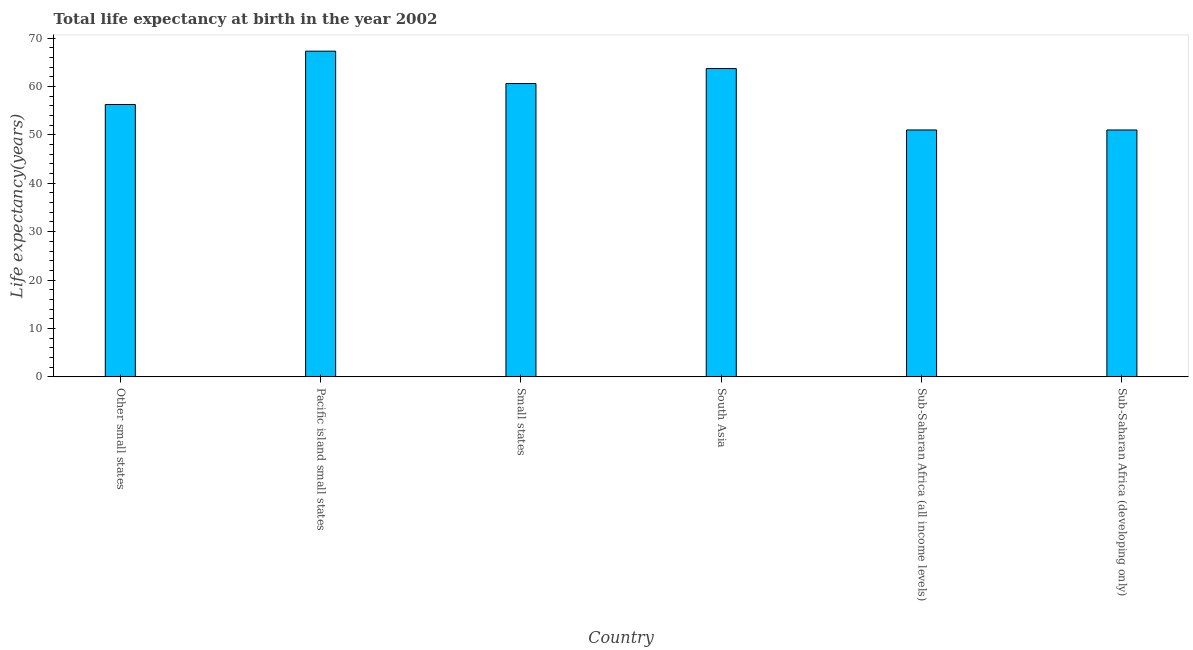Does the graph contain any zero values?
Give a very brief answer. No. What is the title of the graph?
Ensure brevity in your answer.  Total life expectancy at birth in the year 2002. What is the label or title of the X-axis?
Provide a short and direct response. Country. What is the label or title of the Y-axis?
Keep it short and to the point. Life expectancy(years). What is the life expectancy at birth in Small states?
Provide a short and direct response. 60.59. Across all countries, what is the maximum life expectancy at birth?
Provide a succinct answer. 67.28. Across all countries, what is the minimum life expectancy at birth?
Give a very brief answer. 51. In which country was the life expectancy at birth maximum?
Offer a terse response. Pacific island small states. In which country was the life expectancy at birth minimum?
Give a very brief answer. Sub-Saharan Africa (developing only). What is the sum of the life expectancy at birth?
Keep it short and to the point. 349.83. What is the difference between the life expectancy at birth in Other small states and South Asia?
Give a very brief answer. -7.42. What is the average life expectancy at birth per country?
Provide a succinct answer. 58.31. What is the median life expectancy at birth?
Provide a succinct answer. 58.43. What is the ratio of the life expectancy at birth in Pacific island small states to that in South Asia?
Keep it short and to the point. 1.06. What is the difference between the highest and the second highest life expectancy at birth?
Provide a succinct answer. 3.59. Is the sum of the life expectancy at birth in South Asia and Sub-Saharan Africa (all income levels) greater than the maximum life expectancy at birth across all countries?
Provide a succinct answer. Yes. What is the difference between the highest and the lowest life expectancy at birth?
Provide a succinct answer. 16.28. In how many countries, is the life expectancy at birth greater than the average life expectancy at birth taken over all countries?
Your answer should be very brief. 3. How many countries are there in the graph?
Provide a short and direct response. 6. What is the Life expectancy(years) in Other small states?
Make the answer very short. 56.27. What is the Life expectancy(years) of Pacific island small states?
Ensure brevity in your answer.  67.28. What is the Life expectancy(years) in Small states?
Provide a short and direct response. 60.59. What is the Life expectancy(years) in South Asia?
Give a very brief answer. 63.69. What is the Life expectancy(years) in Sub-Saharan Africa (all income levels)?
Ensure brevity in your answer.  51. What is the Life expectancy(years) in Sub-Saharan Africa (developing only)?
Make the answer very short. 51. What is the difference between the Life expectancy(years) in Other small states and Pacific island small states?
Your answer should be very brief. -11.02. What is the difference between the Life expectancy(years) in Other small states and Small states?
Your response must be concise. -4.33. What is the difference between the Life expectancy(years) in Other small states and South Asia?
Keep it short and to the point. -7.42. What is the difference between the Life expectancy(years) in Other small states and Sub-Saharan Africa (all income levels)?
Give a very brief answer. 5.26. What is the difference between the Life expectancy(years) in Other small states and Sub-Saharan Africa (developing only)?
Make the answer very short. 5.27. What is the difference between the Life expectancy(years) in Pacific island small states and Small states?
Offer a very short reply. 6.69. What is the difference between the Life expectancy(years) in Pacific island small states and South Asia?
Your answer should be very brief. 3.59. What is the difference between the Life expectancy(years) in Pacific island small states and Sub-Saharan Africa (all income levels)?
Your answer should be compact. 16.28. What is the difference between the Life expectancy(years) in Pacific island small states and Sub-Saharan Africa (developing only)?
Give a very brief answer. 16.28. What is the difference between the Life expectancy(years) in Small states and South Asia?
Offer a very short reply. -3.1. What is the difference between the Life expectancy(years) in Small states and Sub-Saharan Africa (all income levels)?
Your answer should be very brief. 9.59. What is the difference between the Life expectancy(years) in Small states and Sub-Saharan Africa (developing only)?
Your response must be concise. 9.59. What is the difference between the Life expectancy(years) in South Asia and Sub-Saharan Africa (all income levels)?
Make the answer very short. 12.69. What is the difference between the Life expectancy(years) in South Asia and Sub-Saharan Africa (developing only)?
Ensure brevity in your answer.  12.69. What is the difference between the Life expectancy(years) in Sub-Saharan Africa (all income levels) and Sub-Saharan Africa (developing only)?
Offer a very short reply. 0. What is the ratio of the Life expectancy(years) in Other small states to that in Pacific island small states?
Provide a succinct answer. 0.84. What is the ratio of the Life expectancy(years) in Other small states to that in Small states?
Ensure brevity in your answer.  0.93. What is the ratio of the Life expectancy(years) in Other small states to that in South Asia?
Keep it short and to the point. 0.88. What is the ratio of the Life expectancy(years) in Other small states to that in Sub-Saharan Africa (all income levels)?
Make the answer very short. 1.1. What is the ratio of the Life expectancy(years) in Other small states to that in Sub-Saharan Africa (developing only)?
Offer a terse response. 1.1. What is the ratio of the Life expectancy(years) in Pacific island small states to that in Small states?
Keep it short and to the point. 1.11. What is the ratio of the Life expectancy(years) in Pacific island small states to that in South Asia?
Give a very brief answer. 1.06. What is the ratio of the Life expectancy(years) in Pacific island small states to that in Sub-Saharan Africa (all income levels)?
Make the answer very short. 1.32. What is the ratio of the Life expectancy(years) in Pacific island small states to that in Sub-Saharan Africa (developing only)?
Provide a succinct answer. 1.32. What is the ratio of the Life expectancy(years) in Small states to that in South Asia?
Offer a terse response. 0.95. What is the ratio of the Life expectancy(years) in Small states to that in Sub-Saharan Africa (all income levels)?
Offer a terse response. 1.19. What is the ratio of the Life expectancy(years) in Small states to that in Sub-Saharan Africa (developing only)?
Your response must be concise. 1.19. What is the ratio of the Life expectancy(years) in South Asia to that in Sub-Saharan Africa (all income levels)?
Offer a very short reply. 1.25. What is the ratio of the Life expectancy(years) in South Asia to that in Sub-Saharan Africa (developing only)?
Provide a succinct answer. 1.25. 